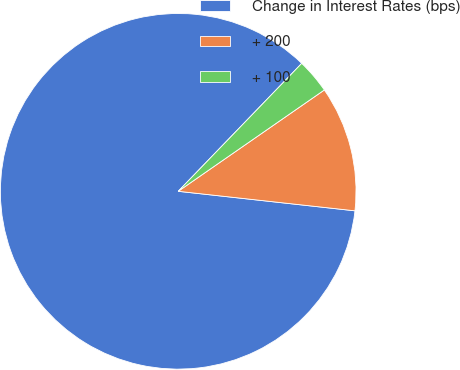Convert chart. <chart><loc_0><loc_0><loc_500><loc_500><pie_chart><fcel>Change in Interest Rates (bps)<fcel>+ 200<fcel>+ 100<nl><fcel>85.47%<fcel>11.4%<fcel>3.13%<nl></chart> 